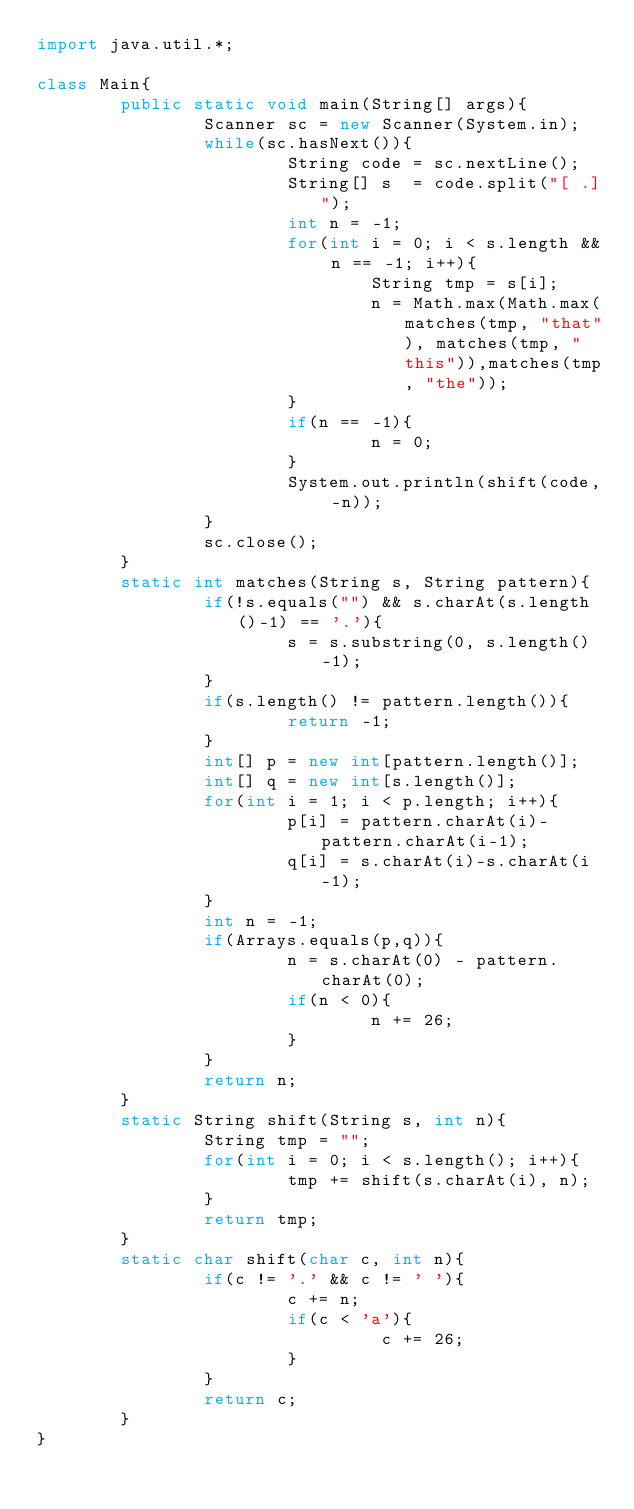<code> <loc_0><loc_0><loc_500><loc_500><_Java_>import java.util.*;

class Main{
        public static void main(String[] args){
                Scanner sc = new Scanner(System.in);
                while(sc.hasNext()){
                        String code = sc.nextLine();
                        String[] s  = code.split("[ .]");
                        int n = -1;
                        for(int i = 0; i < s.length && n == -1; i++){
                                String tmp = s[i];
                                n = Math.max(Math.max(matches(tmp, "that"), matches(tmp, "this")),matches(tmp, "the"));
                        }
                        if(n == -1){
                                n = 0;
                        }
                        System.out.println(shift(code, -n));
                }
                sc.close();
        }
        static int matches(String s, String pattern){
                if(!s.equals("") && s.charAt(s.length()-1) == '.'){
                        s = s.substring(0, s.length()-1);
                }
                if(s.length() != pattern.length()){
                        return -1;
                }
                int[] p = new int[pattern.length()];
                int[] q = new int[s.length()];
                for(int i = 1; i < p.length; i++){
                        p[i] = pattern.charAt(i)-pattern.charAt(i-1);
                        q[i] = s.charAt(i)-s.charAt(i-1);
                }
                int n = -1;
                if(Arrays.equals(p,q)){
                        n = s.charAt(0) - pattern.charAt(0);
                        if(n < 0){
                                n += 26;
                        }
                }
                return n;
        }
        static String shift(String s, int n){
                String tmp = "";
                for(int i = 0; i < s.length(); i++){
                        tmp += shift(s.charAt(i), n);
                }
                return tmp;
        }
        static char shift(char c, int n){
                if(c != '.' && c != ' '){
                        c += n;
                        if(c < 'a'){
                                 c += 26;
                        }
                }
                return c;
        }
}</code> 